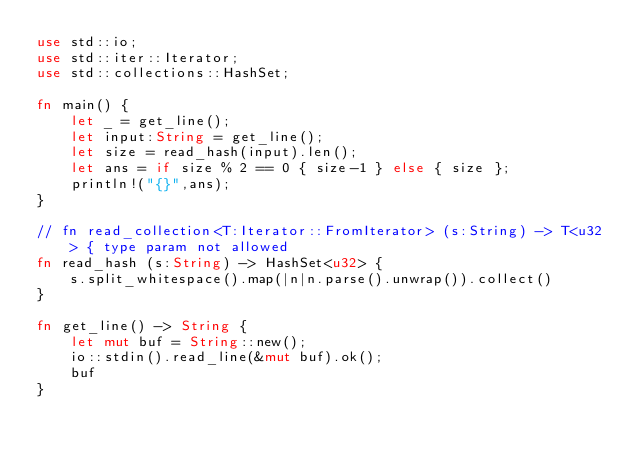Convert code to text. <code><loc_0><loc_0><loc_500><loc_500><_Rust_>use std::io;
use std::iter::Iterator;
use std::collections::HashSet;

fn main() {
    let _ = get_line();
    let input:String = get_line();
    let size = read_hash(input).len();
    let ans = if size % 2 == 0 { size-1 } else { size };
    println!("{}",ans);
}

// fn read_collection<T:Iterator::FromIterator> (s:String) -> T<u32> { type param not allowed
fn read_hash (s:String) -> HashSet<u32> {
    s.split_whitespace().map(|n|n.parse().unwrap()).collect()
}

fn get_line() -> String {
    let mut buf = String::new();
    io::stdin().read_line(&mut buf).ok();
    buf
}</code> 